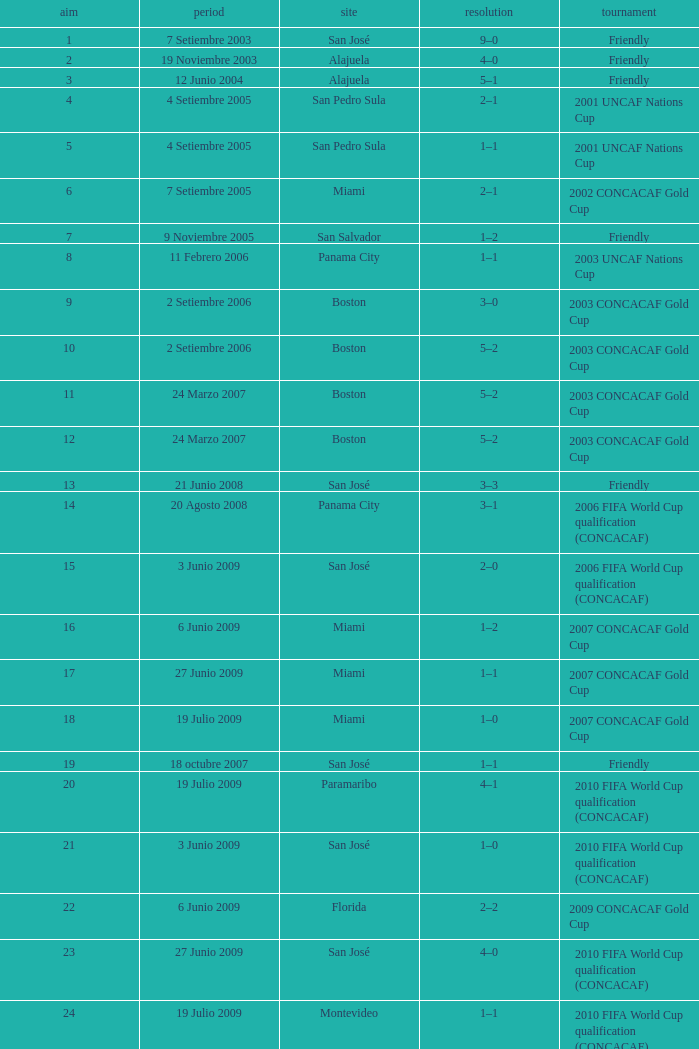How was the competition in which 6 goals were made? 2002 CONCACAF Gold Cup. 